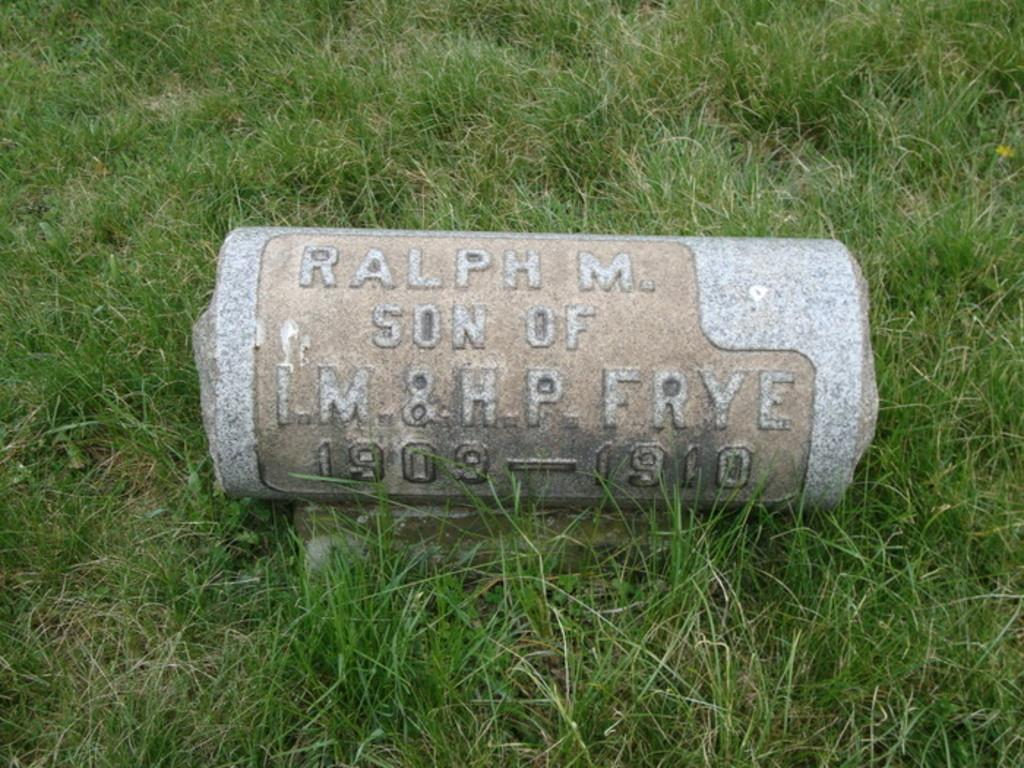What is located on the ground in the image? There is an object on the ground in the image. What type of vegetation can be seen in the background of the image? There is grass visible in the background of the image. What type of pickle is being used as a table in the image? There is no pickle or table present in the image. What type of plough is visible in the image? There is no plough present in the image. 